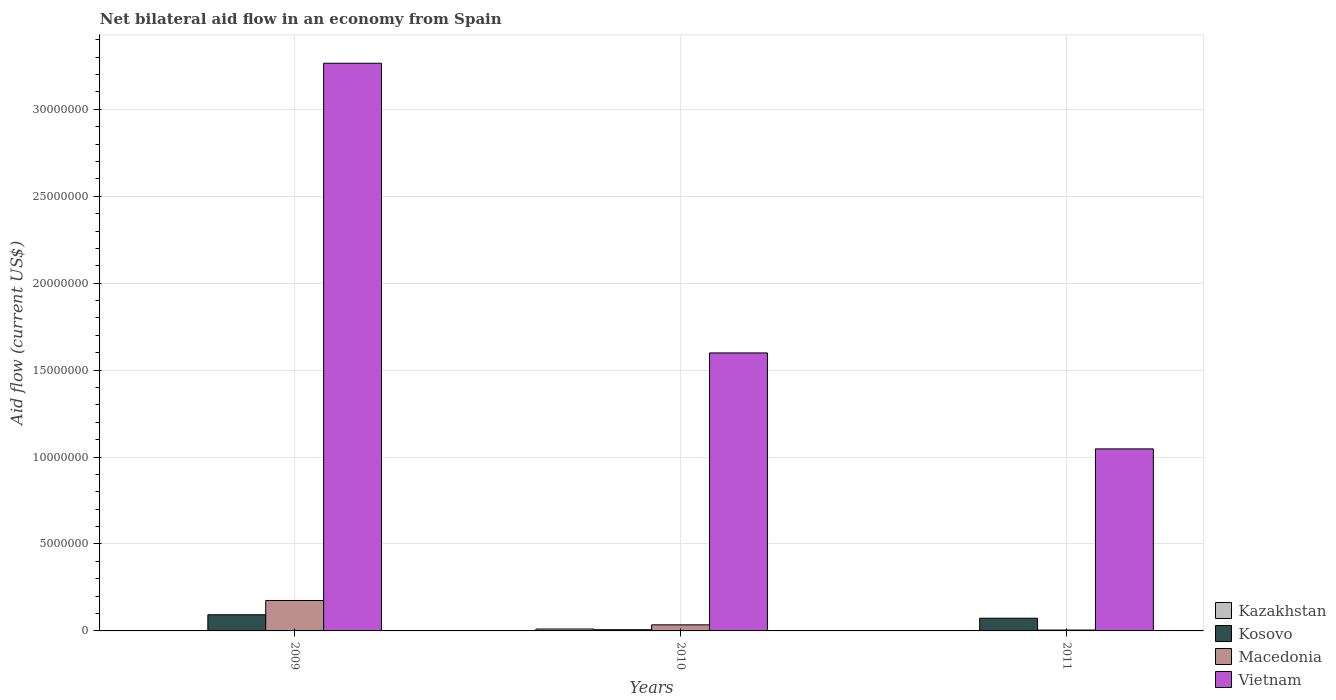Are the number of bars on each tick of the X-axis equal?
Keep it short and to the point. No. How many bars are there on the 3rd tick from the right?
Your answer should be compact. 3. What is the net bilateral aid flow in Kosovo in 2009?
Your answer should be very brief. 9.30e+05. Across all years, what is the maximum net bilateral aid flow in Vietnam?
Give a very brief answer. 3.26e+07. Across all years, what is the minimum net bilateral aid flow in Kosovo?
Ensure brevity in your answer.  7.00e+04. In which year was the net bilateral aid flow in Kazakhstan maximum?
Your answer should be compact. 2010. What is the total net bilateral aid flow in Kosovo in the graph?
Offer a terse response. 1.73e+06. What is the difference between the net bilateral aid flow in Vietnam in 2009 and that in 2010?
Keep it short and to the point. 1.67e+07. What is the difference between the net bilateral aid flow in Kosovo in 2011 and the net bilateral aid flow in Vietnam in 2009?
Give a very brief answer. -3.19e+07. What is the average net bilateral aid flow in Kosovo per year?
Your answer should be compact. 5.77e+05. In how many years, is the net bilateral aid flow in Kazakhstan greater than 31000000 US$?
Offer a terse response. 0. What is the ratio of the net bilateral aid flow in Macedonia in 2010 to that in 2011?
Make the answer very short. 7. What is the difference between the highest and the second highest net bilateral aid flow in Vietnam?
Provide a succinct answer. 1.67e+07. What is the difference between the highest and the lowest net bilateral aid flow in Macedonia?
Offer a terse response. 1.70e+06. How many bars are there?
Your response must be concise. 10. Are all the bars in the graph horizontal?
Make the answer very short. No. How many years are there in the graph?
Give a very brief answer. 3. What is the difference between two consecutive major ticks on the Y-axis?
Your answer should be compact. 5.00e+06. Does the graph contain grids?
Keep it short and to the point. Yes. How many legend labels are there?
Keep it short and to the point. 4. How are the legend labels stacked?
Your answer should be compact. Vertical. What is the title of the graph?
Offer a very short reply. Net bilateral aid flow in an economy from Spain. Does "Malaysia" appear as one of the legend labels in the graph?
Provide a succinct answer. No. What is the Aid flow (current US$) in Kazakhstan in 2009?
Keep it short and to the point. 0. What is the Aid flow (current US$) of Kosovo in 2009?
Your answer should be very brief. 9.30e+05. What is the Aid flow (current US$) of Macedonia in 2009?
Give a very brief answer. 1.75e+06. What is the Aid flow (current US$) in Vietnam in 2009?
Make the answer very short. 3.26e+07. What is the Aid flow (current US$) of Kazakhstan in 2010?
Your answer should be compact. 1.10e+05. What is the Aid flow (current US$) in Kosovo in 2010?
Give a very brief answer. 7.00e+04. What is the Aid flow (current US$) of Vietnam in 2010?
Your answer should be compact. 1.60e+07. What is the Aid flow (current US$) of Kosovo in 2011?
Your answer should be very brief. 7.30e+05. What is the Aid flow (current US$) in Vietnam in 2011?
Your response must be concise. 1.05e+07. Across all years, what is the maximum Aid flow (current US$) of Kosovo?
Keep it short and to the point. 9.30e+05. Across all years, what is the maximum Aid flow (current US$) in Macedonia?
Your answer should be very brief. 1.75e+06. Across all years, what is the maximum Aid flow (current US$) of Vietnam?
Your response must be concise. 3.26e+07. Across all years, what is the minimum Aid flow (current US$) of Vietnam?
Offer a very short reply. 1.05e+07. What is the total Aid flow (current US$) in Kazakhstan in the graph?
Give a very brief answer. 1.10e+05. What is the total Aid flow (current US$) of Kosovo in the graph?
Offer a very short reply. 1.73e+06. What is the total Aid flow (current US$) in Macedonia in the graph?
Make the answer very short. 2.15e+06. What is the total Aid flow (current US$) of Vietnam in the graph?
Provide a succinct answer. 5.91e+07. What is the difference between the Aid flow (current US$) in Kosovo in 2009 and that in 2010?
Provide a succinct answer. 8.60e+05. What is the difference between the Aid flow (current US$) in Macedonia in 2009 and that in 2010?
Make the answer very short. 1.40e+06. What is the difference between the Aid flow (current US$) in Vietnam in 2009 and that in 2010?
Keep it short and to the point. 1.67e+07. What is the difference between the Aid flow (current US$) of Macedonia in 2009 and that in 2011?
Give a very brief answer. 1.70e+06. What is the difference between the Aid flow (current US$) of Vietnam in 2009 and that in 2011?
Offer a terse response. 2.22e+07. What is the difference between the Aid flow (current US$) of Kosovo in 2010 and that in 2011?
Provide a succinct answer. -6.60e+05. What is the difference between the Aid flow (current US$) of Macedonia in 2010 and that in 2011?
Offer a terse response. 3.00e+05. What is the difference between the Aid flow (current US$) of Vietnam in 2010 and that in 2011?
Your answer should be compact. 5.52e+06. What is the difference between the Aid flow (current US$) in Kosovo in 2009 and the Aid flow (current US$) in Macedonia in 2010?
Your response must be concise. 5.80e+05. What is the difference between the Aid flow (current US$) of Kosovo in 2009 and the Aid flow (current US$) of Vietnam in 2010?
Offer a terse response. -1.51e+07. What is the difference between the Aid flow (current US$) of Macedonia in 2009 and the Aid flow (current US$) of Vietnam in 2010?
Your answer should be very brief. -1.42e+07. What is the difference between the Aid flow (current US$) of Kosovo in 2009 and the Aid flow (current US$) of Macedonia in 2011?
Your answer should be compact. 8.80e+05. What is the difference between the Aid flow (current US$) of Kosovo in 2009 and the Aid flow (current US$) of Vietnam in 2011?
Keep it short and to the point. -9.54e+06. What is the difference between the Aid flow (current US$) in Macedonia in 2009 and the Aid flow (current US$) in Vietnam in 2011?
Give a very brief answer. -8.72e+06. What is the difference between the Aid flow (current US$) of Kazakhstan in 2010 and the Aid flow (current US$) of Kosovo in 2011?
Your answer should be compact. -6.20e+05. What is the difference between the Aid flow (current US$) in Kazakhstan in 2010 and the Aid flow (current US$) in Vietnam in 2011?
Offer a very short reply. -1.04e+07. What is the difference between the Aid flow (current US$) of Kosovo in 2010 and the Aid flow (current US$) of Macedonia in 2011?
Offer a very short reply. 2.00e+04. What is the difference between the Aid flow (current US$) in Kosovo in 2010 and the Aid flow (current US$) in Vietnam in 2011?
Ensure brevity in your answer.  -1.04e+07. What is the difference between the Aid flow (current US$) in Macedonia in 2010 and the Aid flow (current US$) in Vietnam in 2011?
Provide a short and direct response. -1.01e+07. What is the average Aid flow (current US$) of Kazakhstan per year?
Your answer should be compact. 3.67e+04. What is the average Aid flow (current US$) in Kosovo per year?
Provide a succinct answer. 5.77e+05. What is the average Aid flow (current US$) of Macedonia per year?
Offer a very short reply. 7.17e+05. What is the average Aid flow (current US$) of Vietnam per year?
Make the answer very short. 1.97e+07. In the year 2009, what is the difference between the Aid flow (current US$) in Kosovo and Aid flow (current US$) in Macedonia?
Provide a succinct answer. -8.20e+05. In the year 2009, what is the difference between the Aid flow (current US$) in Kosovo and Aid flow (current US$) in Vietnam?
Provide a succinct answer. -3.17e+07. In the year 2009, what is the difference between the Aid flow (current US$) in Macedonia and Aid flow (current US$) in Vietnam?
Your answer should be compact. -3.09e+07. In the year 2010, what is the difference between the Aid flow (current US$) of Kazakhstan and Aid flow (current US$) of Macedonia?
Offer a terse response. -2.40e+05. In the year 2010, what is the difference between the Aid flow (current US$) of Kazakhstan and Aid flow (current US$) of Vietnam?
Offer a very short reply. -1.59e+07. In the year 2010, what is the difference between the Aid flow (current US$) of Kosovo and Aid flow (current US$) of Macedonia?
Keep it short and to the point. -2.80e+05. In the year 2010, what is the difference between the Aid flow (current US$) of Kosovo and Aid flow (current US$) of Vietnam?
Provide a short and direct response. -1.59e+07. In the year 2010, what is the difference between the Aid flow (current US$) in Macedonia and Aid flow (current US$) in Vietnam?
Provide a succinct answer. -1.56e+07. In the year 2011, what is the difference between the Aid flow (current US$) of Kosovo and Aid flow (current US$) of Macedonia?
Offer a terse response. 6.80e+05. In the year 2011, what is the difference between the Aid flow (current US$) in Kosovo and Aid flow (current US$) in Vietnam?
Give a very brief answer. -9.74e+06. In the year 2011, what is the difference between the Aid flow (current US$) in Macedonia and Aid flow (current US$) in Vietnam?
Keep it short and to the point. -1.04e+07. What is the ratio of the Aid flow (current US$) of Kosovo in 2009 to that in 2010?
Give a very brief answer. 13.29. What is the ratio of the Aid flow (current US$) of Macedonia in 2009 to that in 2010?
Make the answer very short. 5. What is the ratio of the Aid flow (current US$) in Vietnam in 2009 to that in 2010?
Your answer should be compact. 2.04. What is the ratio of the Aid flow (current US$) in Kosovo in 2009 to that in 2011?
Your response must be concise. 1.27. What is the ratio of the Aid flow (current US$) in Vietnam in 2009 to that in 2011?
Keep it short and to the point. 3.12. What is the ratio of the Aid flow (current US$) of Kosovo in 2010 to that in 2011?
Your answer should be compact. 0.1. What is the ratio of the Aid flow (current US$) of Macedonia in 2010 to that in 2011?
Make the answer very short. 7. What is the ratio of the Aid flow (current US$) in Vietnam in 2010 to that in 2011?
Offer a very short reply. 1.53. What is the difference between the highest and the second highest Aid flow (current US$) of Kosovo?
Your response must be concise. 2.00e+05. What is the difference between the highest and the second highest Aid flow (current US$) of Macedonia?
Offer a very short reply. 1.40e+06. What is the difference between the highest and the second highest Aid flow (current US$) of Vietnam?
Make the answer very short. 1.67e+07. What is the difference between the highest and the lowest Aid flow (current US$) of Kosovo?
Offer a very short reply. 8.60e+05. What is the difference between the highest and the lowest Aid flow (current US$) in Macedonia?
Give a very brief answer. 1.70e+06. What is the difference between the highest and the lowest Aid flow (current US$) in Vietnam?
Keep it short and to the point. 2.22e+07. 